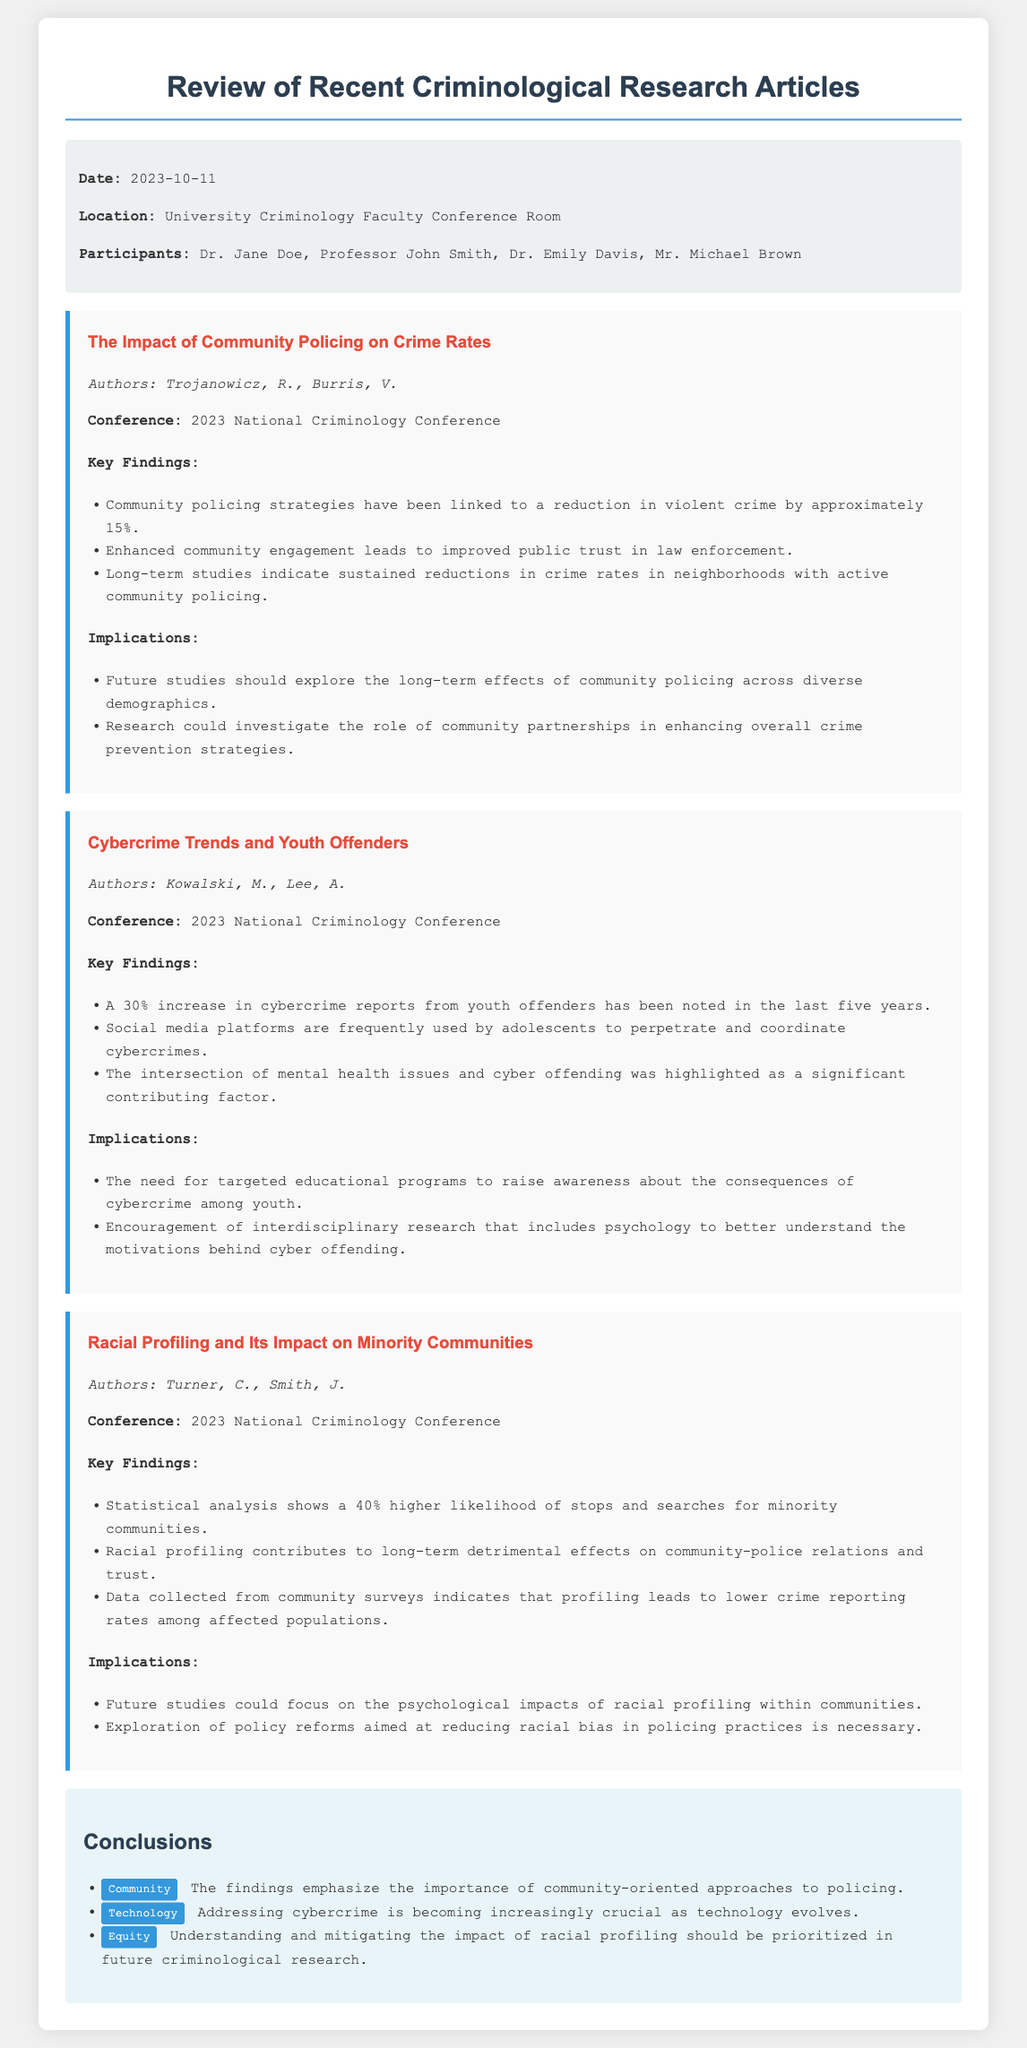What is the date of the meeting? The date of the meeting is mentioned in the document's metadata section.
Answer: 2023-10-11 Who were the participants in the meeting? The participants listed in the document's metadata section include four individuals.
Answer: Dr. Jane Doe, Professor John Smith, Dr. Emily Davis, Mr. Michael Brown What is the title of the first article reviewed? The title of the first article is clearly stated in the document under the first article section.
Answer: The Impact of Community Policing on Crime Rates What percentage reduction in violent crime is linked to community policing strategies? The document specifies the percentage reduction found in the key findings of the first article.
Answer: Approximately 15% What trend is highlighted regarding youth offenders and cybercrime? The document provides insights into the trends observed in the second article's key findings regarding youth offenders.
Answer: A 30% increase in cybercrime reports What is one implication of racial profiling discussed in the document? The implications of racial profiling are summarized in the corresponding section of the third article reviewed.
Answer: Exploration of policy reforms aimed at reducing racial bias in policing practices is necessary Which article discusses the relationship between mental health issues and cyber offending? The second article emphasizes the relationship mentioned in its key findings.
Answer: Cybercrime Trends and Youth Offenders What are the three tags mentioned in the conclusions section? The tags give a quick thematic overview of the conclusions drawn from the reviewed articles in the document.
Answer: Community, Technology, Equity 